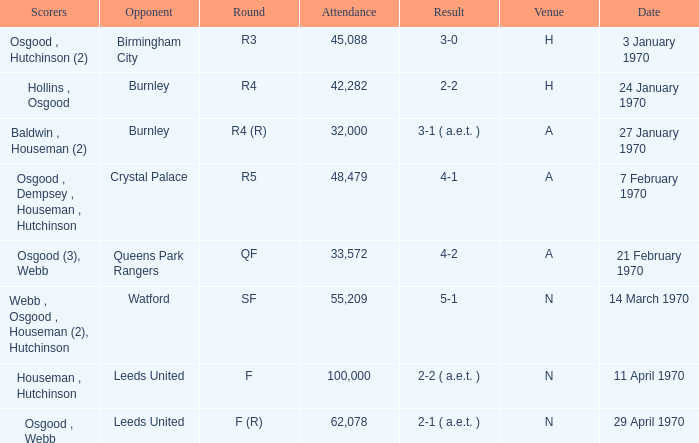What round was the game with a result of 5-1 at N venue? SF. 